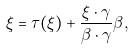<formula> <loc_0><loc_0><loc_500><loc_500>\xi = \tau ( \xi ) + \frac { \xi \cdot \gamma } { \beta \cdot \gamma } \beta ,</formula> 